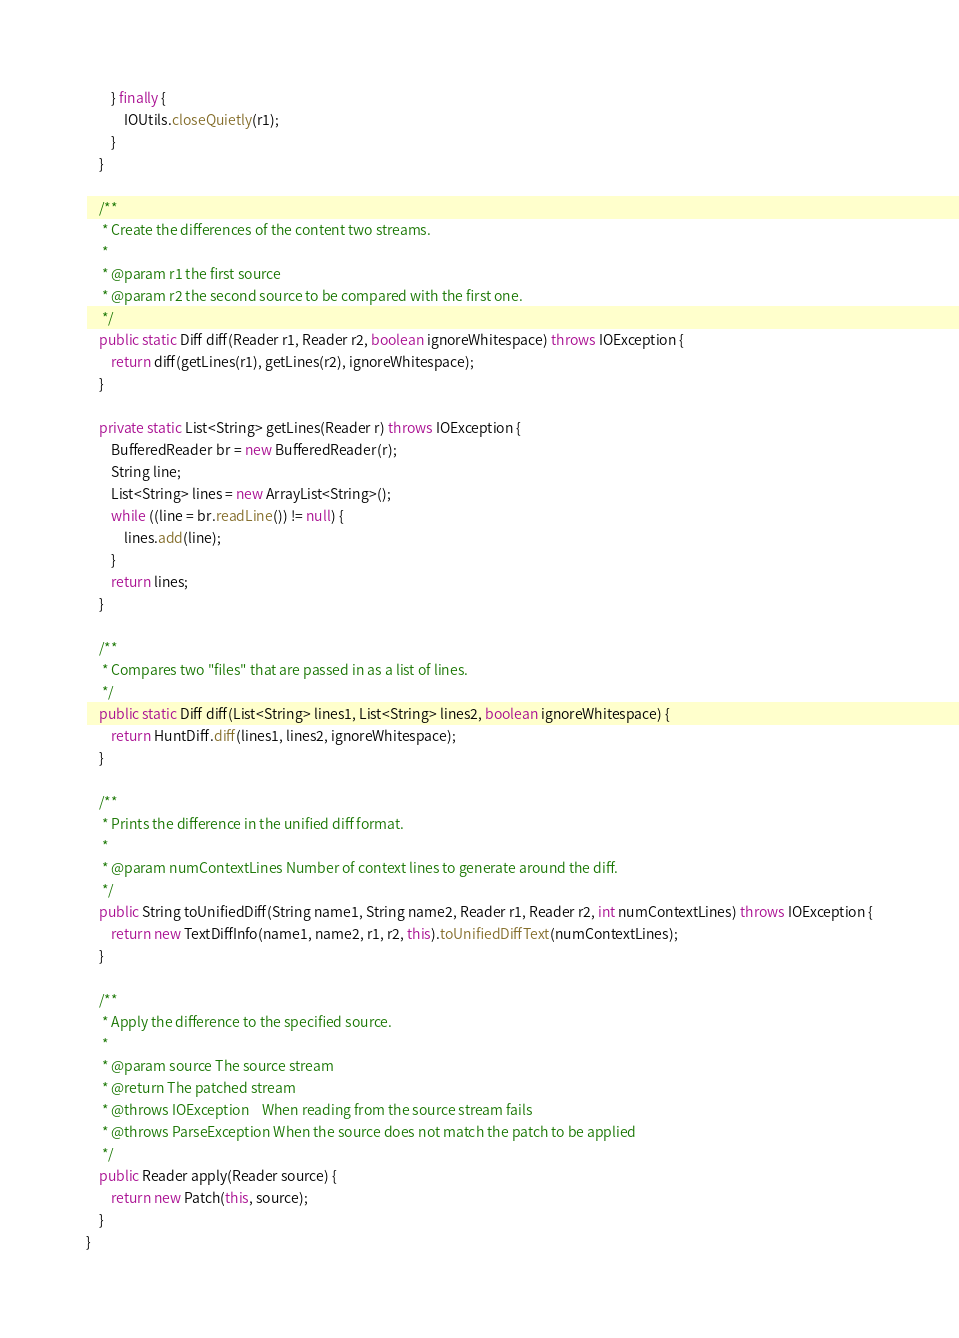Convert code to text. <code><loc_0><loc_0><loc_500><loc_500><_Java_>        } finally {
            IOUtils.closeQuietly(r1);
        }
    }

    /**
     * Create the differences of the content two streams.
     *
     * @param r1 the first source
     * @param r2 the second source to be compared with the first one.
     */
    public static Diff diff(Reader r1, Reader r2, boolean ignoreWhitespace) throws IOException {
        return diff(getLines(r1), getLines(r2), ignoreWhitespace);
    }

    private static List<String> getLines(Reader r) throws IOException {
        BufferedReader br = new BufferedReader(r);
        String line;
        List<String> lines = new ArrayList<String>();
        while ((line = br.readLine()) != null) {
            lines.add(line);
        }
        return lines;
    }

    /**
     * Compares two "files" that are passed in as a list of lines.
     */
    public static Diff diff(List<String> lines1, List<String> lines2, boolean ignoreWhitespace) {
        return HuntDiff.diff(lines1, lines2, ignoreWhitespace);
    }

    /**
     * Prints the difference in the unified diff format.
     *
     * @param numContextLines Number of context lines to generate around the diff.
     */
    public String toUnifiedDiff(String name1, String name2, Reader r1, Reader r2, int numContextLines) throws IOException {
        return new TextDiffInfo(name1, name2, r1, r2, this).toUnifiedDiffText(numContextLines);
    }

    /**
     * Apply the difference to the specified source.
     *
     * @param source The source stream
     * @return The patched stream
     * @throws IOException    When reading from the source stream fails
     * @throws ParseException When the source does not match the patch to be applied
     */
    public Reader apply(Reader source) {
        return new Patch(this, source);
    }
}
</code> 